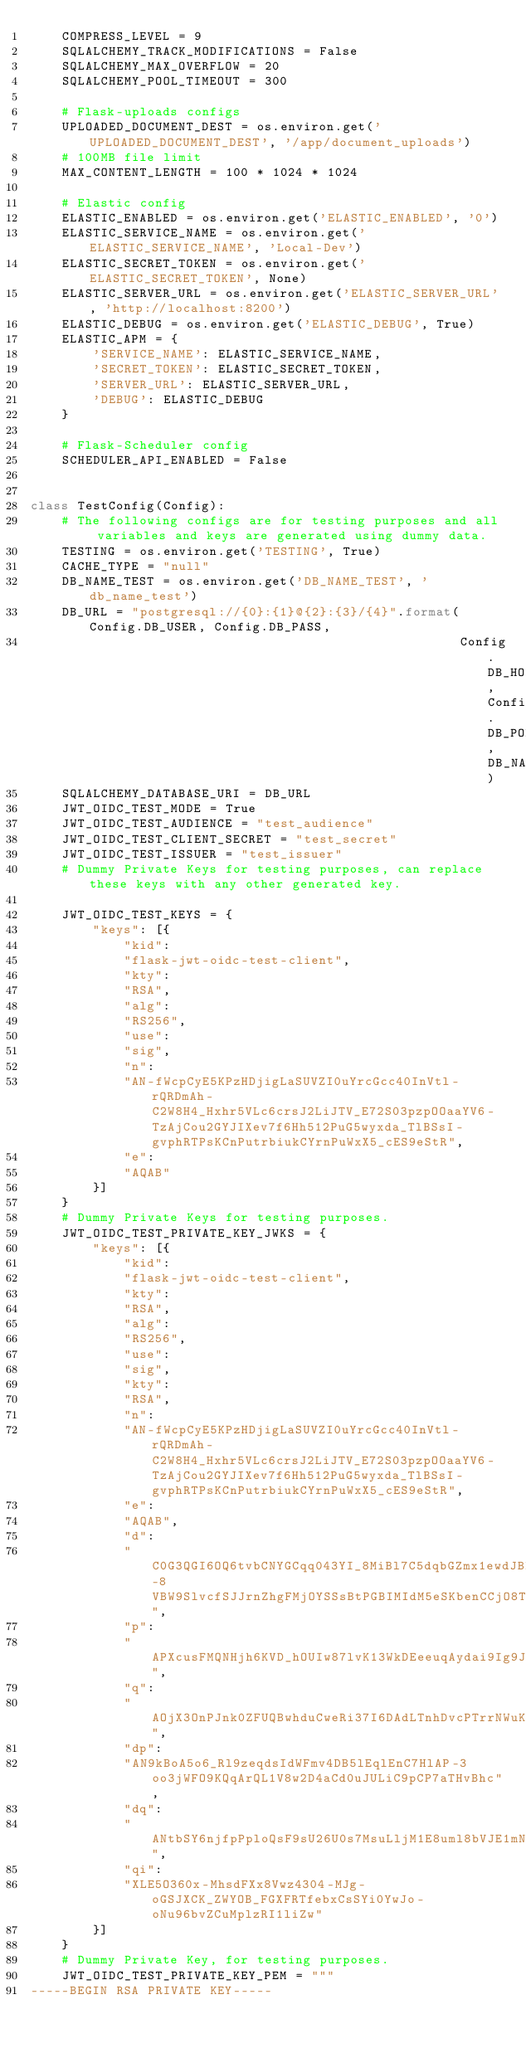<code> <loc_0><loc_0><loc_500><loc_500><_Python_>    COMPRESS_LEVEL = 9
    SQLALCHEMY_TRACK_MODIFICATIONS = False
    SQLALCHEMY_MAX_OVERFLOW = 20
    SQLALCHEMY_POOL_TIMEOUT = 300

    # Flask-uploads configs
    UPLOADED_DOCUMENT_DEST = os.environ.get('UPLOADED_DOCUMENT_DEST', '/app/document_uploads')
    # 100MB file limit
    MAX_CONTENT_LENGTH = 100 * 1024 * 1024

    # Elastic config
    ELASTIC_ENABLED = os.environ.get('ELASTIC_ENABLED', '0')
    ELASTIC_SERVICE_NAME = os.environ.get('ELASTIC_SERVICE_NAME', 'Local-Dev')
    ELASTIC_SECRET_TOKEN = os.environ.get('ELASTIC_SECRET_TOKEN', None)
    ELASTIC_SERVER_URL = os.environ.get('ELASTIC_SERVER_URL', 'http://localhost:8200')
    ELASTIC_DEBUG = os.environ.get('ELASTIC_DEBUG', True)
    ELASTIC_APM = {
        'SERVICE_NAME': ELASTIC_SERVICE_NAME,
        'SECRET_TOKEN': ELASTIC_SECRET_TOKEN,
        'SERVER_URL': ELASTIC_SERVER_URL,
        'DEBUG': ELASTIC_DEBUG
    }

    # Flask-Scheduler config
    SCHEDULER_API_ENABLED = False


class TestConfig(Config):
    # The following configs are for testing purposes and all variables and keys are generated using dummy data.
    TESTING = os.environ.get('TESTING', True)
    CACHE_TYPE = "null"
    DB_NAME_TEST = os.environ.get('DB_NAME_TEST', 'db_name_test')
    DB_URL = "postgresql://{0}:{1}@{2}:{3}/{4}".format(Config.DB_USER, Config.DB_PASS,
                                                       Config.DB_HOST, Config.DB_PORT, DB_NAME_TEST)
    SQLALCHEMY_DATABASE_URI = DB_URL
    JWT_OIDC_TEST_MODE = True
    JWT_OIDC_TEST_AUDIENCE = "test_audience"
    JWT_OIDC_TEST_CLIENT_SECRET = "test_secret"
    JWT_OIDC_TEST_ISSUER = "test_issuer"
    # Dummy Private Keys for testing purposes, can replace these keys with any other generated key.

    JWT_OIDC_TEST_KEYS = {
        "keys": [{
            "kid":
            "flask-jwt-oidc-test-client",
            "kty":
            "RSA",
            "alg":
            "RS256",
            "use":
            "sig",
            "n":
            "AN-fWcpCyE5KPzHDjigLaSUVZI0uYrcGcc40InVtl-rQRDmAh-C2W8H4_Hxhr5VLc6crsJ2LiJTV_E72S03pzpOOaaYV6-TzAjCou2GYJIXev7f6Hh512PuG5wyxda_TlBSsI-gvphRTPsKCnPutrbiukCYrnPuWxX5_cES9eStR",
            "e":
            "AQAB"
        }]
    }
    # Dummy Private Keys for testing purposes.
    JWT_OIDC_TEST_PRIVATE_KEY_JWKS = {
        "keys": [{
            "kid":
            "flask-jwt-oidc-test-client",
            "kty":
            "RSA",
            "alg":
            "RS256",
            "use":
            "sig",
            "kty":
            "RSA",
            "n":
            "AN-fWcpCyE5KPzHDjigLaSUVZI0uYrcGcc40InVtl-rQRDmAh-C2W8H4_Hxhr5VLc6crsJ2LiJTV_E72S03pzpOOaaYV6-TzAjCou2GYJIXev7f6Hh512PuG5wyxda_TlBSsI-gvphRTPsKCnPutrbiukCYrnPuWxX5_cES9eStR",
            "e":
            "AQAB",
            "d":
            "C0G3QGI6OQ6tvbCNYGCqq043YI_8MiBl7C5dqbGZmx1ewdJBhMNJPStuckhskURaDwk4-8VBW9SlvcfSJJrnZhgFMjOYSSsBtPGBIMIdM5eSKbenCCjO8Tg0BUh_xa3CHST1W4RQ5rFXadZ9AeNtaGcWj2acmXNO3DVETXAX3x0",
            "p":
            "APXcusFMQNHjh6KVD_hOUIw87lvK13WkDEeeuqAydai9Ig9JKEAAfV94W6Aftka7tGgE7ulg1vo3eJoLWJ1zvKM",
            "q":
            "AOjX3OnPJnk0ZFUQBwhduCweRi37I6DAdLTnhDvcPTrrNWuKPg9uGwHjzFCJgKd8KBaDQ0X1rZTZLTqi3peT43s",
            "dp":
            "AN9kBoA5o6_Rl9zeqdsIdWFmv4DB5lEqlEnC7HlAP-3oo3jWFO9KQqArQL1V8w2D4aCd0uJULiC9pCP7aTHvBhc",
            "dq":
            "ANtbSY6njfpPploQsF9sU26U0s7MsuLljM1E8uml8bVJE1mNsiu9MgpUvg39jEu9BtM2tDD7Y51AAIEmIQex1nM",
            "qi":
            "XLE5O360x-MhsdFXx8Vwz4304-MJg-oGSJXCK_ZWYOB_FGXFRTfebxCsSYi0YwJo-oNu96bvZCuMplzRI1liZw"
        }]
    }
    # Dummy Private Key, for testing purposes.
    JWT_OIDC_TEST_PRIVATE_KEY_PEM = """
-----BEGIN RSA PRIVATE KEY-----</code> 